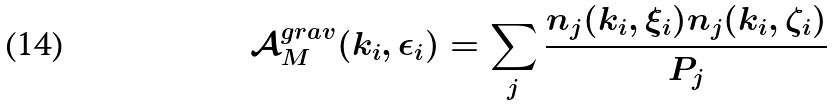Convert formula to latex. <formula><loc_0><loc_0><loc_500><loc_500>\mathcal { A } ^ { g r a v } _ { M } ( k _ { i } , \epsilon _ { i } ) = \sum _ { j } \frac { n _ { j } ( k _ { i } , \xi _ { i } ) n _ { j } ( k _ { i } , \zeta _ { i } ) } { P _ { j } }</formula> 